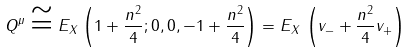Convert formula to latex. <formula><loc_0><loc_0><loc_500><loc_500>Q ^ { \mu } \cong E _ { X } \left ( 1 + \frac { n ^ { 2 } } { 4 } ; 0 , 0 , - 1 + \frac { n ^ { 2 } } { 4 } \right ) = E _ { X } \, \left ( v _ { - } + \frac { n ^ { 2 } } { 4 } v _ { + } \right )</formula> 